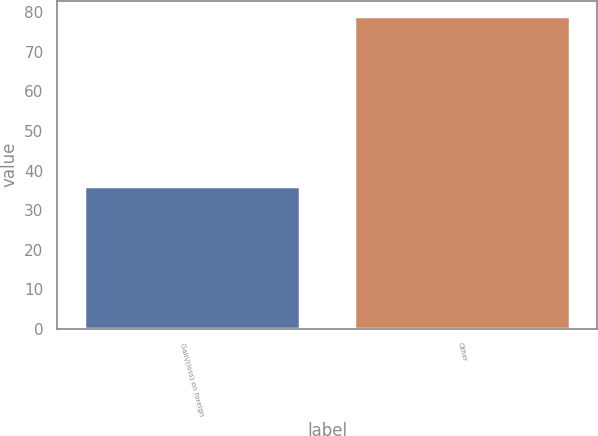Convert chart. <chart><loc_0><loc_0><loc_500><loc_500><bar_chart><fcel>Gain/(loss) on foreign<fcel>Other<nl><fcel>36<fcel>79<nl></chart> 